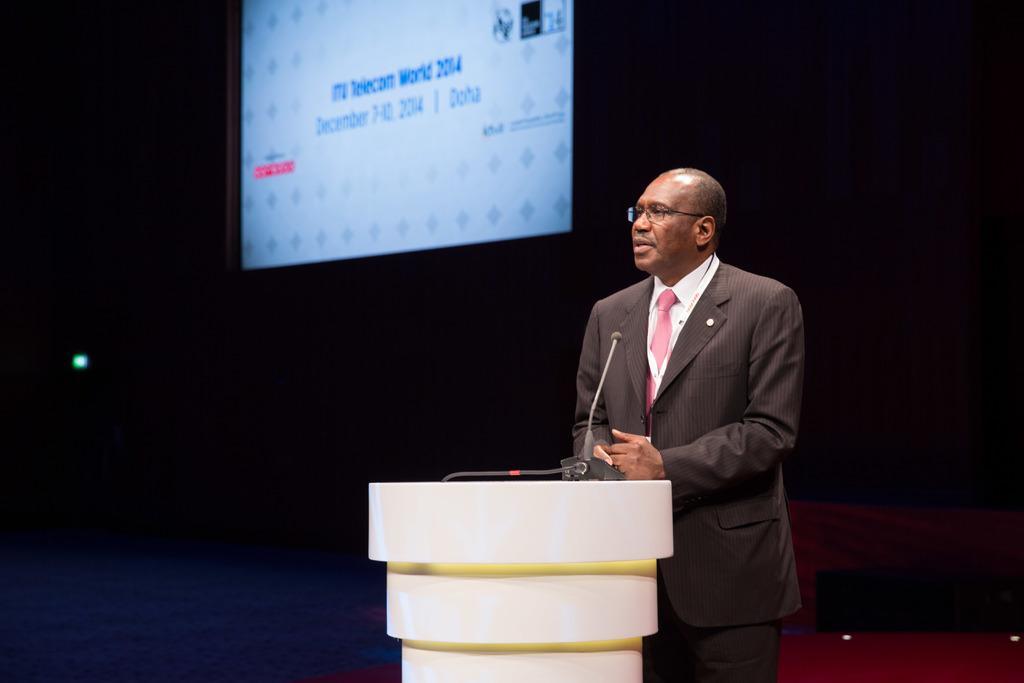Could you give a brief overview of what you see in this image? In-front of this man there is a podium with mic. Here we can see a screen. 